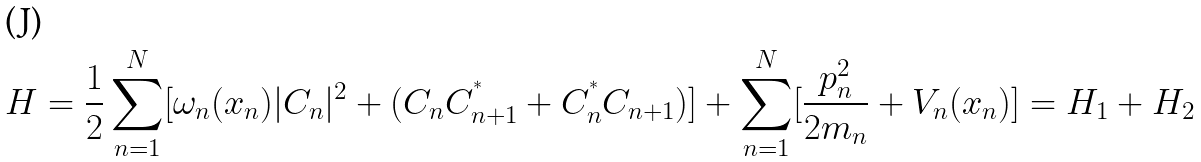<formula> <loc_0><loc_0><loc_500><loc_500>H = \frac { 1 } { 2 } \sum _ { n = 1 } ^ { N } [ \omega _ { n } ( x _ { n } ) | C _ { n } | ^ { 2 } + ( C _ { n } C _ { n + 1 } ^ { ^ { * } } + C _ { n } ^ { ^ { * } } C _ { n + 1 } ) ] + \sum _ { n = 1 } ^ { N } [ \frac { p _ { n } ^ { 2 } } { 2 m _ { n } } + V _ { n } ( x _ { n } ) ] = H _ { 1 } + H _ { 2 }</formula> 